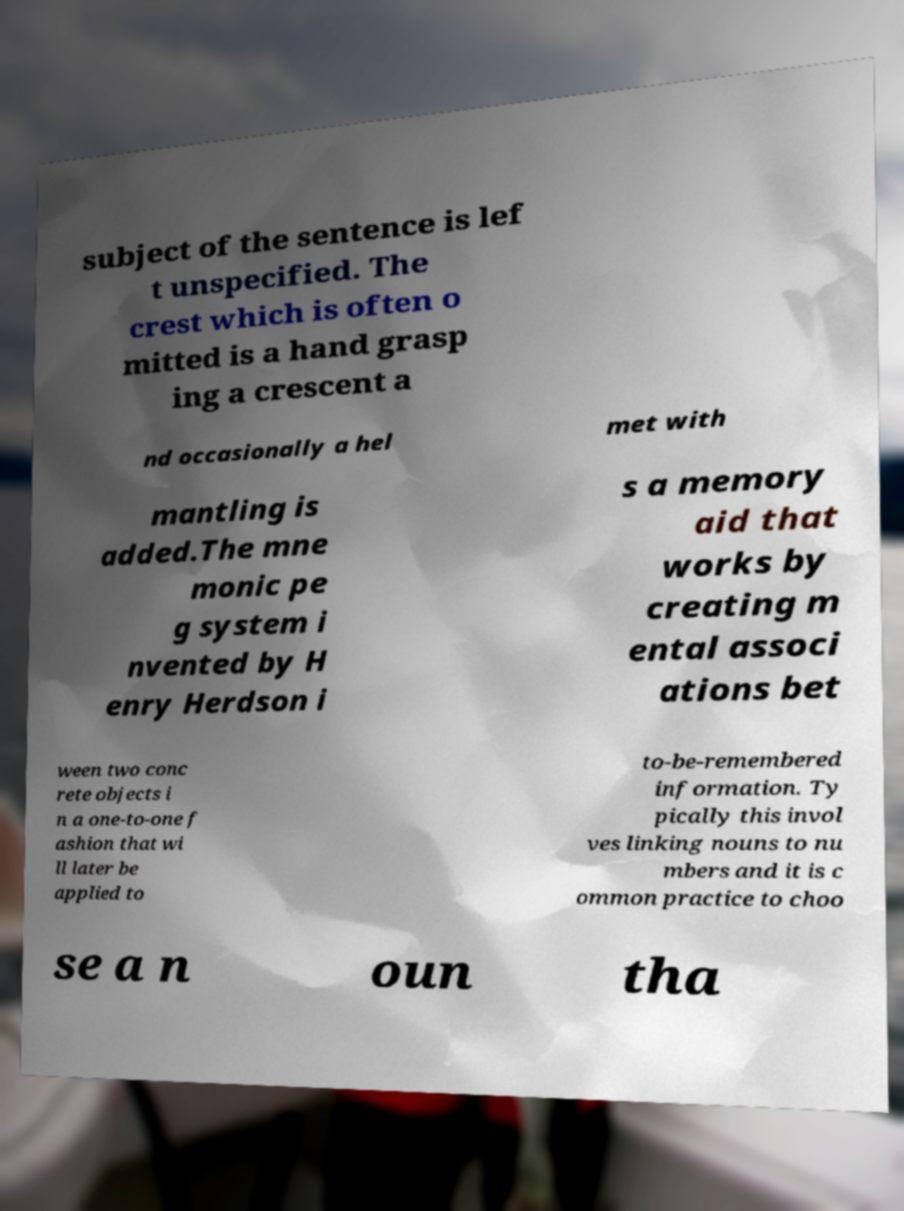For documentation purposes, I need the text within this image transcribed. Could you provide that? subject of the sentence is lef t unspecified. The crest which is often o mitted is a hand grasp ing a crescent a nd occasionally a hel met with mantling is added.The mne monic pe g system i nvented by H enry Herdson i s a memory aid that works by creating m ental associ ations bet ween two conc rete objects i n a one-to-one f ashion that wi ll later be applied to to-be-remembered information. Ty pically this invol ves linking nouns to nu mbers and it is c ommon practice to choo se a n oun tha 